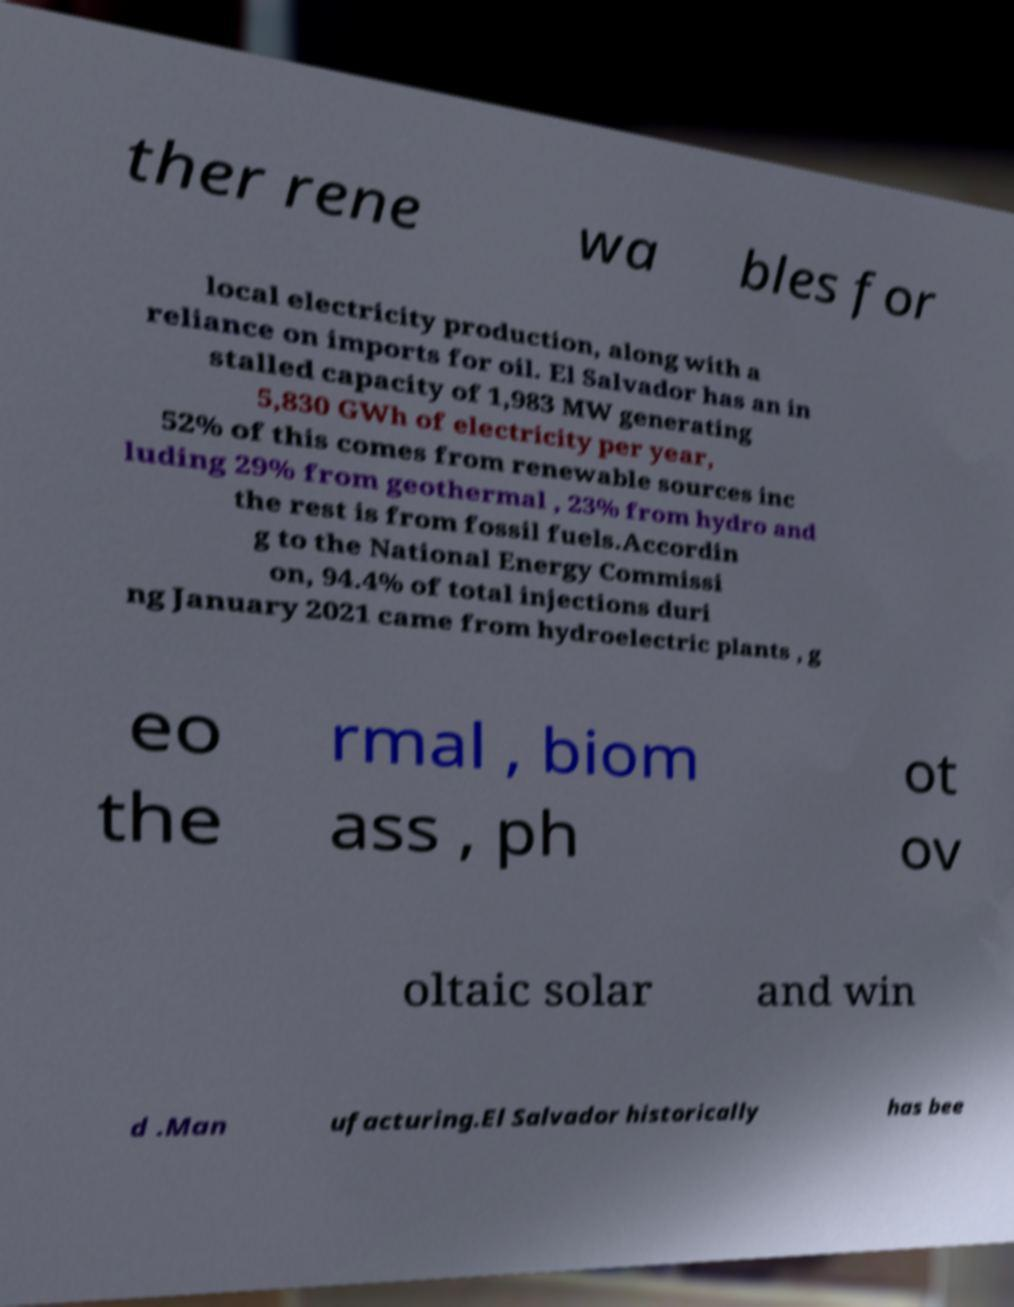Please read and relay the text visible in this image. What does it say? ther rene wa bles for local electricity production, along with a reliance on imports for oil. El Salvador has an in stalled capacity of 1,983 MW generating 5,830 GWh of electricity per year, 52% of this comes from renewable sources inc luding 29% from geothermal , 23% from hydro and the rest is from fossil fuels.Accordin g to the National Energy Commissi on, 94.4% of total injections duri ng January 2021 came from hydroelectric plants , g eo the rmal , biom ass , ph ot ov oltaic solar and win d .Man ufacturing.El Salvador historically has bee 